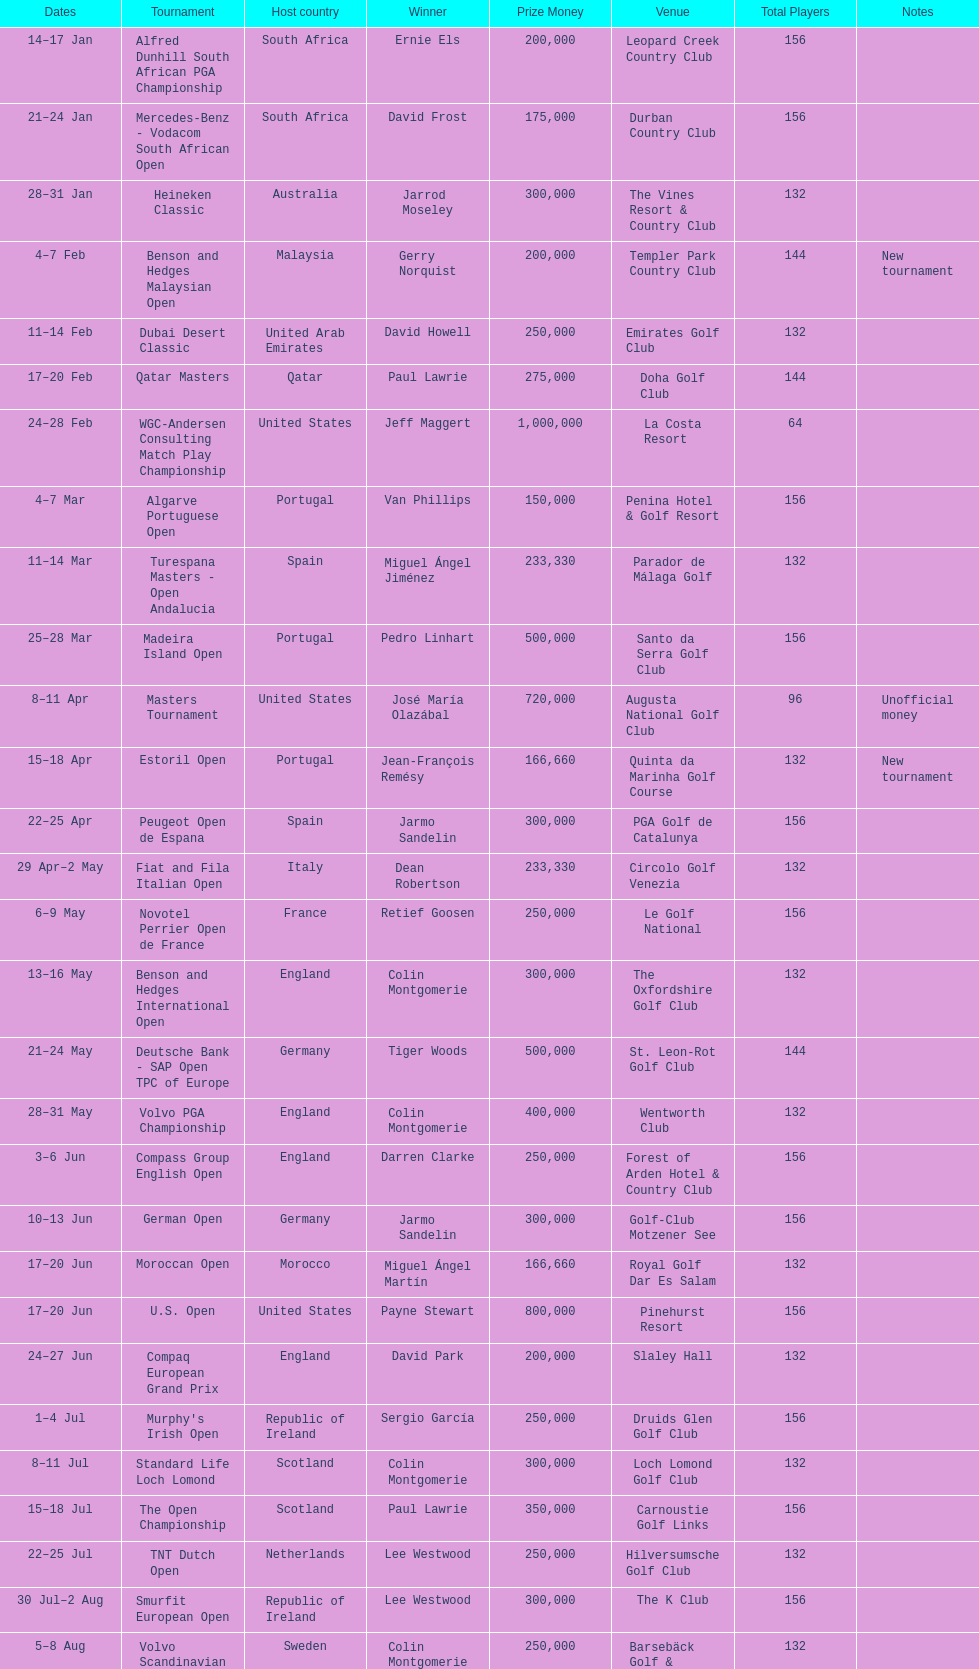Does any nation possess more than 5 victors? Yes. 